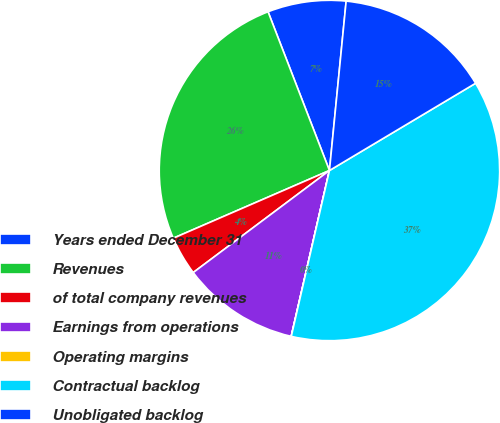Convert chart to OTSL. <chart><loc_0><loc_0><loc_500><loc_500><pie_chart><fcel>Years ended December 31<fcel>Revenues<fcel>of total company revenues<fcel>Earnings from operations<fcel>Operating margins<fcel>Contractual backlog<fcel>Unobligated backlog<nl><fcel>7.44%<fcel>25.64%<fcel>3.72%<fcel>11.16%<fcel>0.01%<fcel>37.17%<fcel>14.87%<nl></chart> 